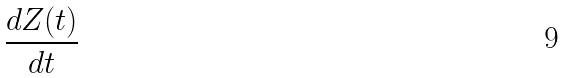<formula> <loc_0><loc_0><loc_500><loc_500>\frac { d Z ( t ) } { d t }</formula> 